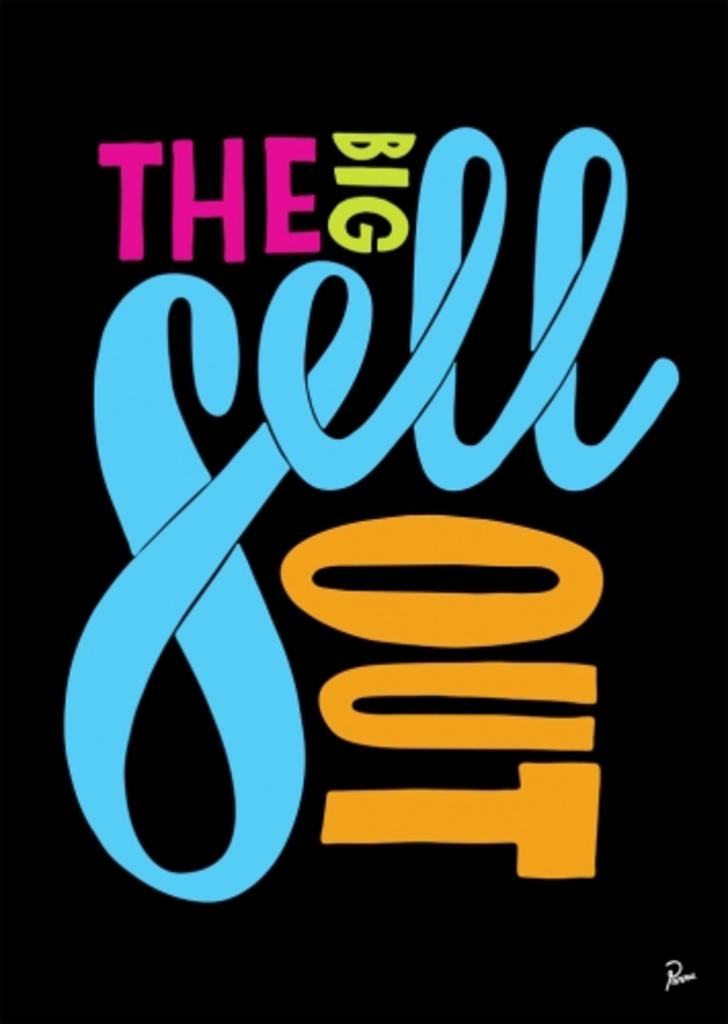<image>
Share a concise interpretation of the image provided. Black background with an orange word that says "OUT". 